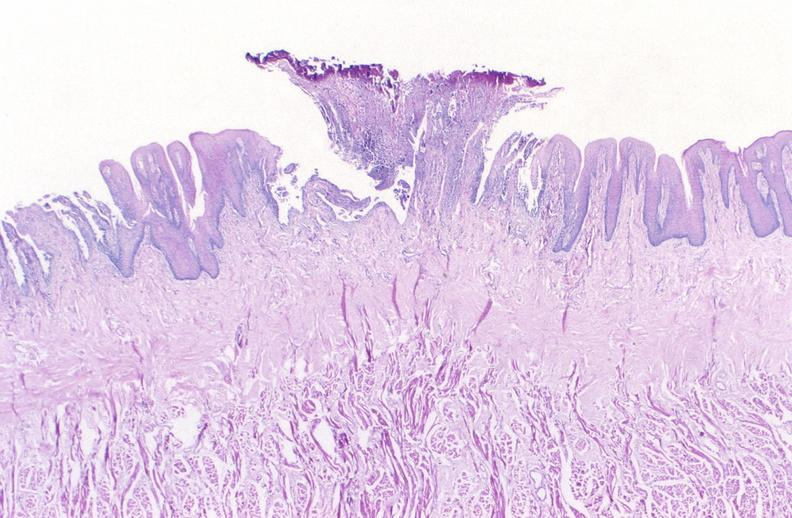s gastrointestinal present?
Answer the question using a single word or phrase. Yes 